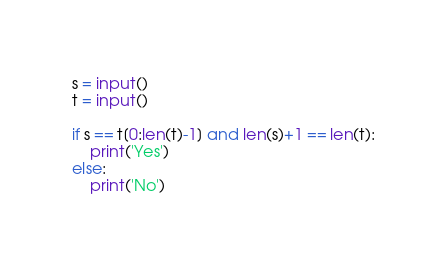Convert code to text. <code><loc_0><loc_0><loc_500><loc_500><_Python_>
s = input()
t = input()

if s == t[0:len(t)-1] and len(s)+1 == len(t):
    print('Yes')
else:
    print('No')</code> 